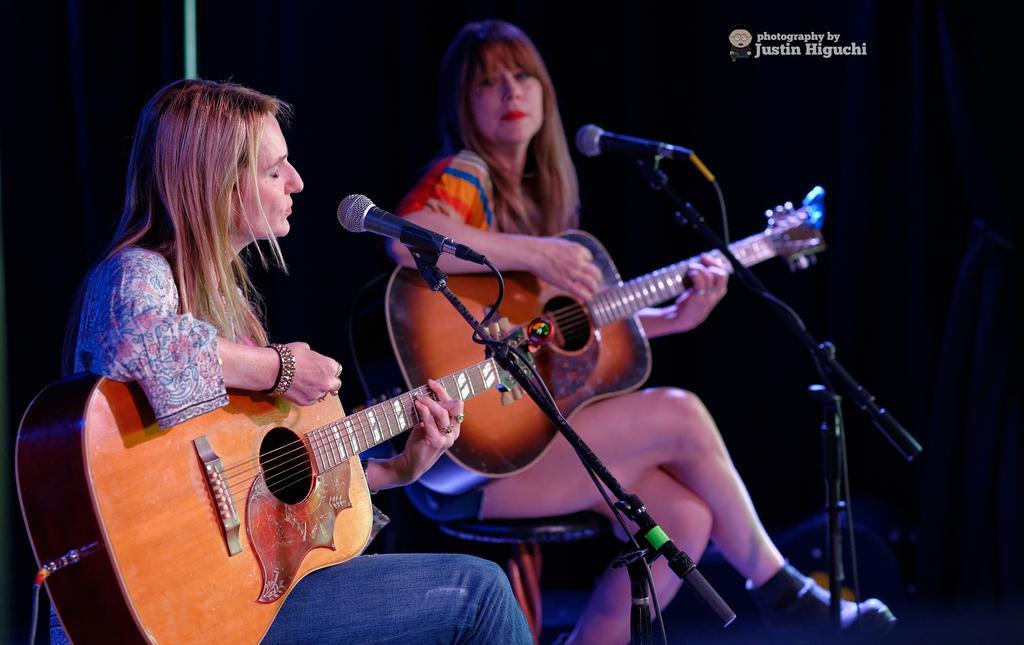Please provide a concise description of this image. In this image I can see two women are sitting on chairs, I can also see both of them are holding guitars. Here I can see two mics in front of them. 